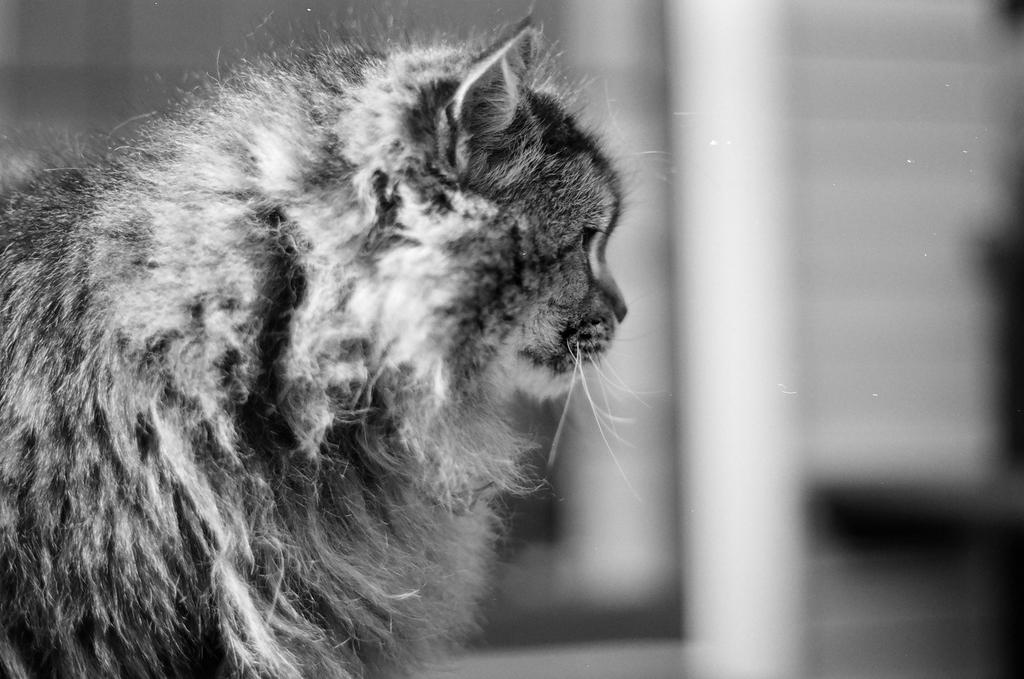What is the color scheme of the image? The image is black and white. What animal can be seen in the image? There is a cat in the image. Can you describe the background of the image? The background of the image is blurry. Are there any cobwebs visible in the image? There are no cobwebs present in the image. What type of shock can be seen in the image? There is no shock present in the image. 